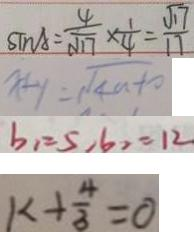<formula> <loc_0><loc_0><loc_500><loc_500>\sin A = \frac { 4 } { \sqrt { 1 7 } } \times \frac { 1 } { 4 } = \frac { \sqrt { 1 7 } } { 1 7 } 
 x + y = \sqrt { 4 n - 1 0 } 
 b _ { 1 } = 5 , 6 _ { 2 } = 1 2 
 k + \frac { 4 } { 3 } = 0</formula> 